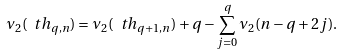<formula> <loc_0><loc_0><loc_500><loc_500>\nu _ { 2 } ( \ t h _ { q , n } ) = \nu _ { 2 } ( \ t h _ { q + 1 , n } ) + q - \sum _ { j = 0 } ^ { q } \nu _ { 2 } ( n - q + 2 j ) .</formula> 